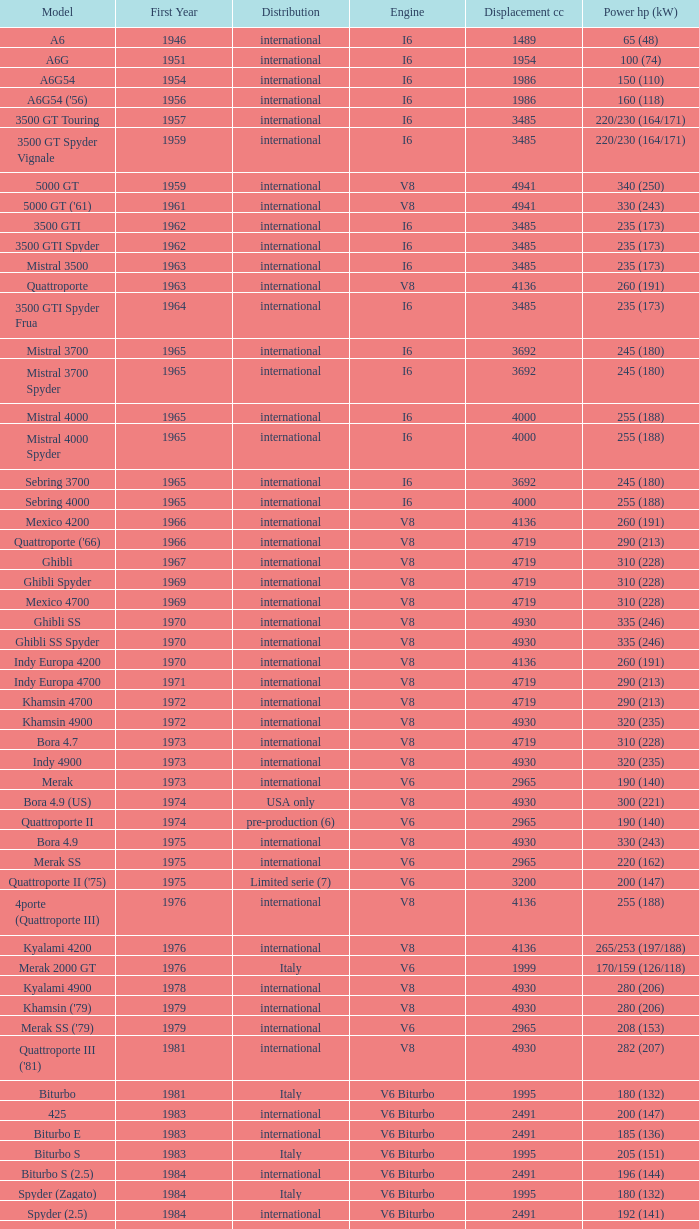When the first year is beyond 1965, distribution is "international", engine is v6 biturbo, and model is "425", what is the power hp (kw)? 200 (147). 